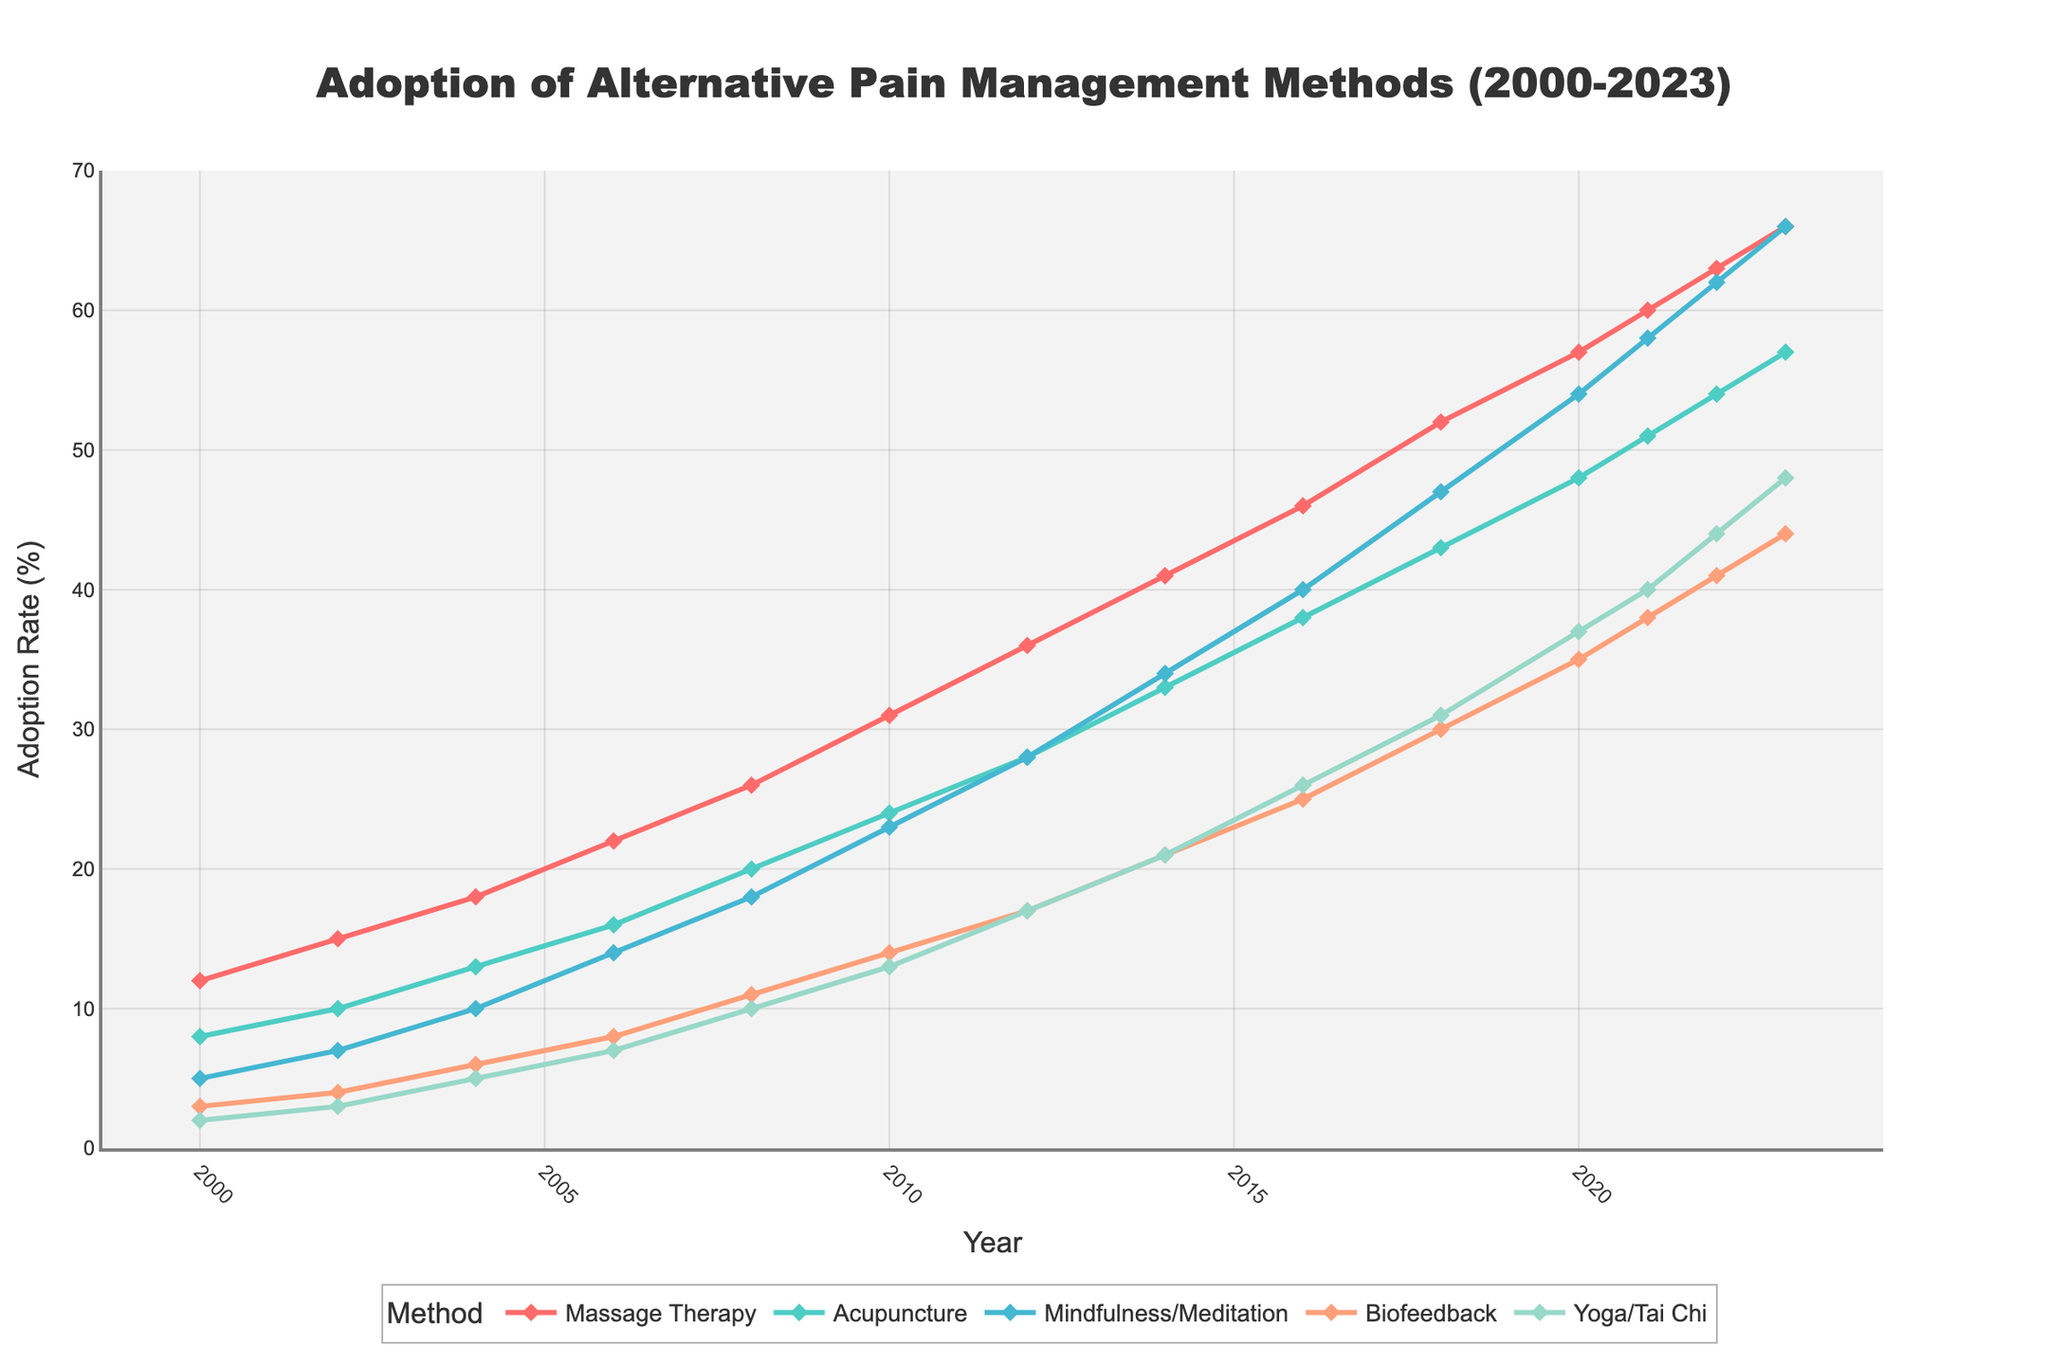Which pain management method had the highest adoption rate in 2023? Look at the data points for each method in 2023 and identify the highest value. Massage Therapy has the highest adoption rate at 66%.
Answer: Massage Therapy How did the adoption rate of Yoga/Tai Chi in 2020 compare to that of Biofeedback in the same year? Compare the data points for Yoga/Tai Chi and Biofeedback in 2020. Yoga/Tai Chi is at 37%, while Biofeedback is at 35%.
Answer: Yoga/Tai Chi is higher What is the average adoption rate of Acupuncture between 2000 and 2023? Sum the adoption rates of Acupuncture from 2000 to 2023 and divide by the number of years (14). (8+10+13+16+20+24+28+33+38+43+48+51+54+57)/14 = 33.5
Answer: 33.5 Which year saw the highest increase in adoption rate for Massage Therapy? Calculate the year-over-year increase in adoption rates for Massage Therapy and identify the year with the highest increase. The biggest increase of 9 happened from 2016 (46) to 2018 (52).
Answer: 2018 What is the combined adoption rate of Mindfulness/Meditation and Biofeedback in 2014? Add the adoption rates of Mindfulness/Meditation (21) and Biofeedback (34) in 2014. 21+34 = 55
Answer: 55 Between 2000 and 2023, in which year did Mindfulness/Meditation surpass Biofeedback in adoption rate? Compare the data points for Mindfulness/Meditation and Biofeedback year by year to find the first instance when Mindfulness/Meditation has a higher value. This first occurs in 2018 (47 vs. 30).
Answer: 2018 What is the difference in the adoption rates of Acupuncture between 2008 and 2018? Subtract the adoption rate of Acupuncture in 2008 (20) from the rate in 2018 (43). 43-20 = 23
Answer: 23 Which two pain management methods had an equal adoption rate in any given year, and what was the rate? Identify if any two methods have the same adoption rate in a given year by comparing their data points year by year. Mindfulness/Meditation and Yoga/Tai Chi both had an adoption rate of 17 in 2012.
Answer: Mindfulness/Meditation and Yoga/Tai Chi at 17 in 2012 How much did the adoption rate for Biofeedback change from 2000 to 2023? Subtract the adoption rate of Biofeedback in 2000 (3) from the rate in 2023 (44). 44-3 = 41
Answer: 41 Which method had the smallest rate of change in adoption rate between 2000 and 2023? Calculate the difference between 2000 and 2023 for each method and identify the smallest change. Yoga/Tai Chi changed by 48-2 = 46, the smallest among all.
Answer: Yoga/Tai Chi 